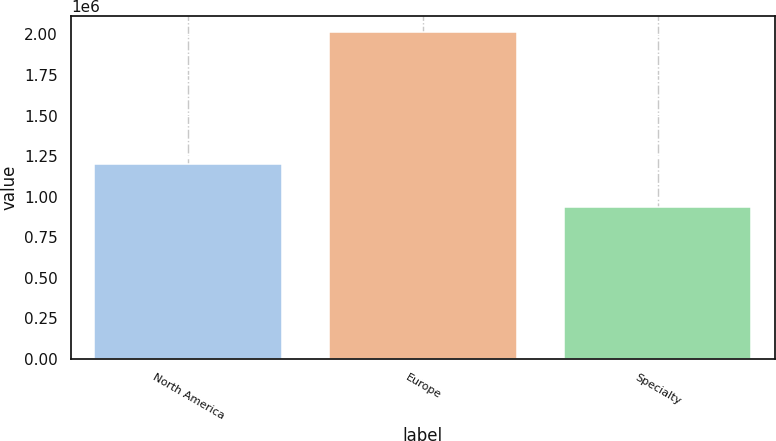Convert chart to OTSL. <chart><loc_0><loc_0><loc_500><loc_500><bar_chart><fcel>North America<fcel>Europe<fcel>Specialty<nl><fcel>1.19856e+06<fcel>2.0128e+06<fcel>934119<nl></chart> 